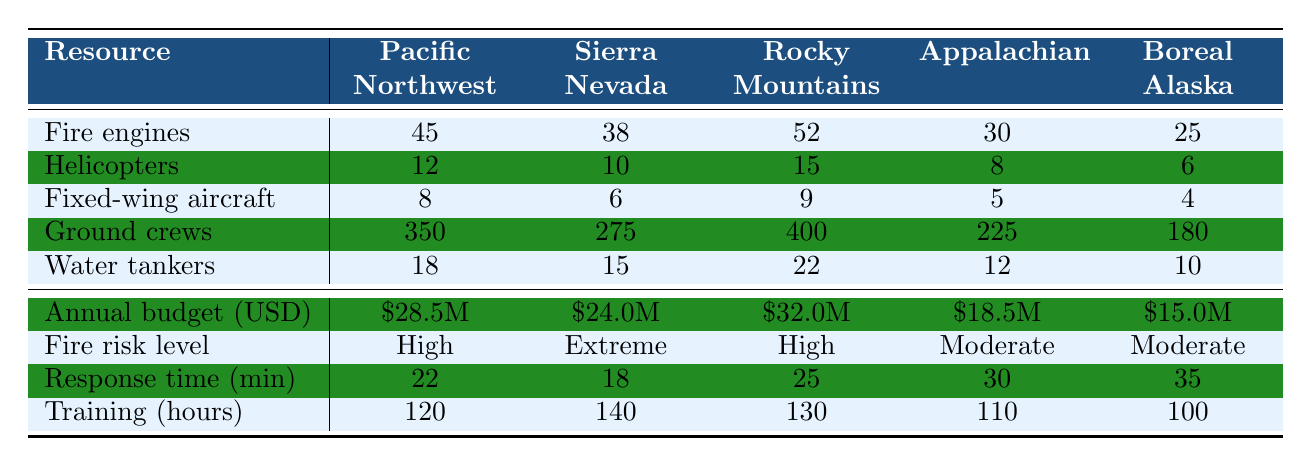What is the highest number of fire engines allocated in a single forest zone? The highest value in the "Fire engines" row corresponds to the Rocky Mountains, which has 52 fire engines.
Answer: 52 Which forest zone has the lowest budget allocation? The annual budget allocations can be examined, and Boreal Alaska has the lowest allocation at $15 million.
Answer: $15 million How many more helicopters are allocated in the Rocky Mountains compared to the Sierra Nevada? The Rocky Mountains has 15 helicopters, and the Sierra Nevada has 10. The difference is 15 - 10 = 5.
Answer: 5 What is the fire risk level in the Pacific Northwest? The table shows that the fire risk level in the Pacific Northwest is classified as High.
Answer: High What is the total number of ground crews across all forest zones? To find the total, sum the numbers: 350 (Pacific Northwest) + 275 (Sierra Nevada) + 400 (Rocky Mountains) + 225 (Appalachian) + 180 (Boreal Alaska) = 1420.
Answer: 1420 Which forest zone has the longest response time? The response times indicate that Boreal Alaska has the longest response time at 35 minutes.
Answer: 35 minutes Is the number of fixed-wing aircraft higher in Sierra Nevada than in Appalachian? The Sierra Nevada has 6 fixed-wing aircraft and Appalachian has 5. Yes, 6 > 5.
Answer: Yes What is the average training hours for firefighters across all zones? Calculate the average by summing the training hours: 120 + 140 + 130 + 110 + 100 = 600, then divide by 5 (the number of zones): 600 / 5 = 120.
Answer: 120 In which forest zone does the allocation of water tankers equal the highest when compared to the others? Review the water tanker allocations: Pacific Northwest has 18, Sierra Nevada has 15, Rocky Mountains has 22, Appalachian has 12, and Boreal Alaska has 10. The highest is in the Rocky Mountains with 22.
Answer: Rocky Mountains If the training hours increase by 10 in each zone, what would be the new training hours for Sierra Nevada? The current training hours for Sierra Nevada is 140. Adding 10 would yield 140 + 10 = 150.
Answer: 150 